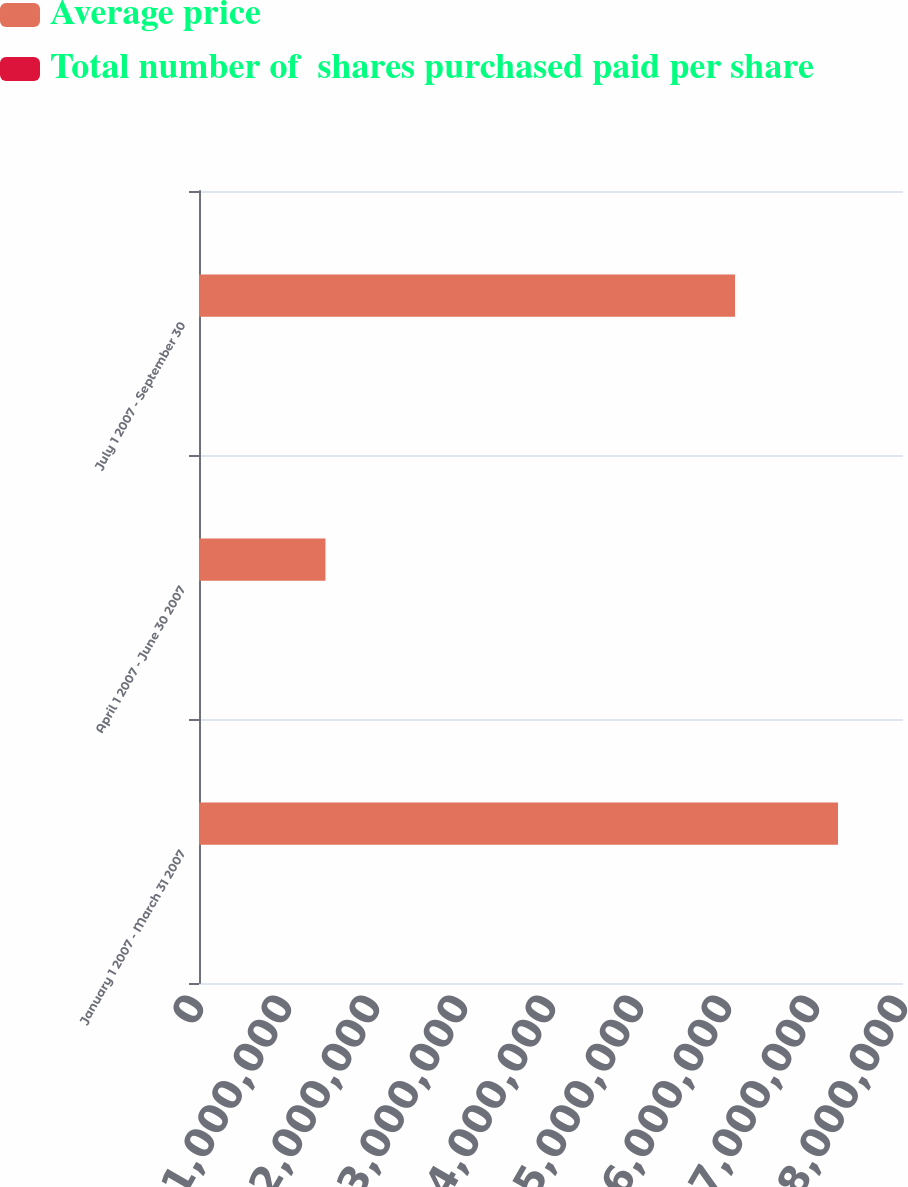Convert chart to OTSL. <chart><loc_0><loc_0><loc_500><loc_500><stacked_bar_chart><ecel><fcel>January 1 2007 - March 31 2007<fcel>April 1 2007 - June 30 2007<fcel>July 1 2007 - September 30<nl><fcel>Average price<fcel>7.26145e+06<fcel>1.4371e+06<fcel>6.0914e+06<nl><fcel>Total number of  shares purchased paid per share<fcel>43.24<fcel>48.86<fcel>47.21<nl></chart> 